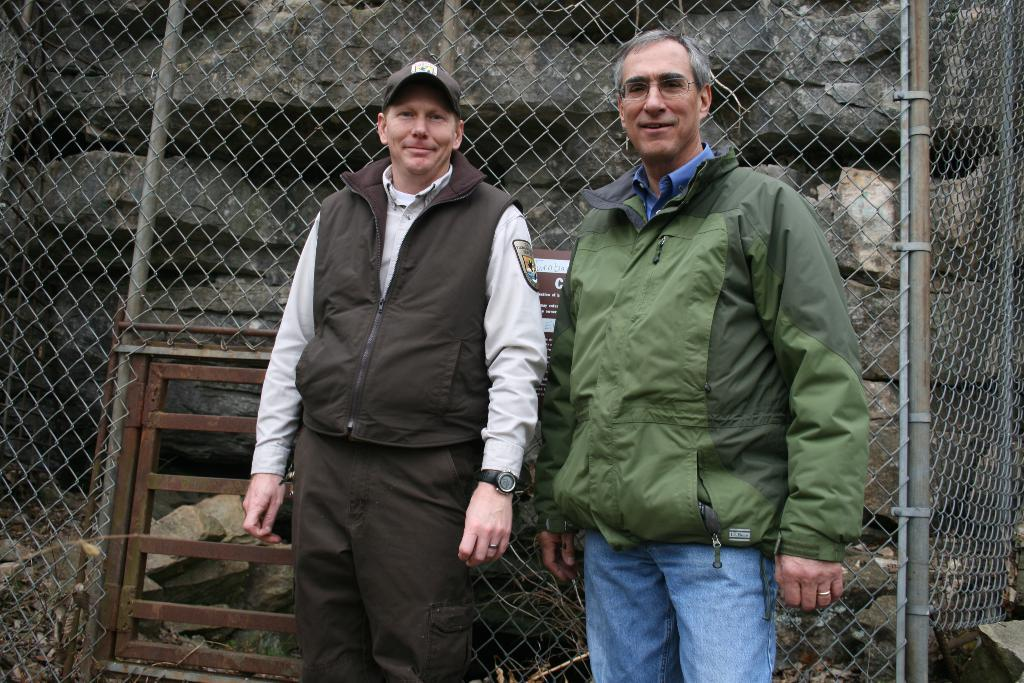How many people are in the image? There are two men in the image. What are the men doing in the image? The men are standing in the image. What expressions do the men have in the image? Both men are smiling in the image. What can be seen in the background of the image? There is fencing and rocks in the background of the image. What type of lizards can be seen crawling on the men in the image? There are no lizards present in the image; the men are standing without any lizards crawling on them. What sound do the men make when they see the lizards in the image? There are no lizards present in the image, so the men do not make any sounds related to lizards. 